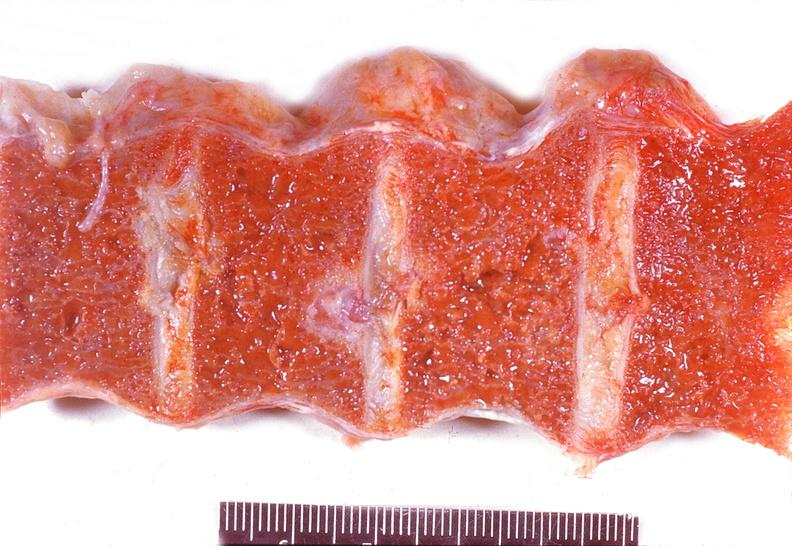what is present?
Answer the question using a single word or phrase. Joints 